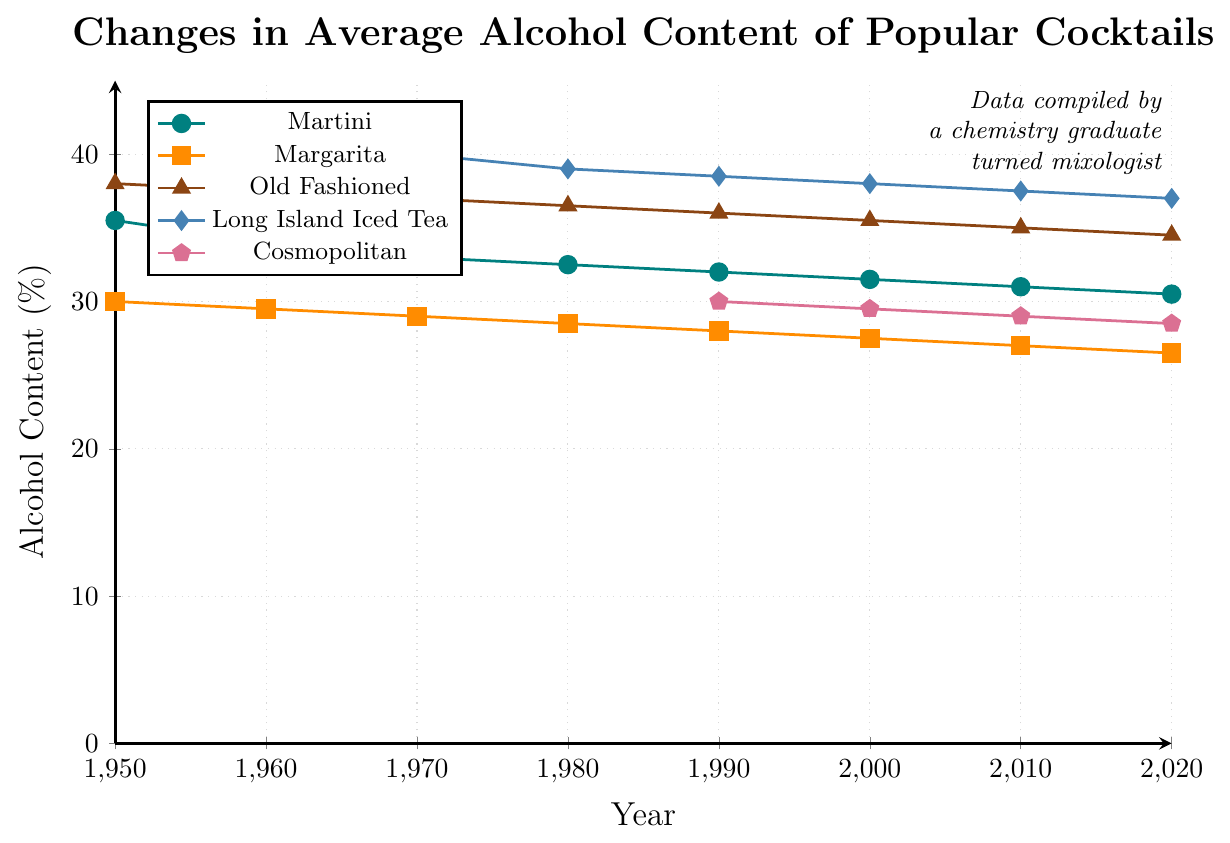Which cocktail had the highest alcohol content in 1950? Find the highest data point in the year 1950; Old Fashioned has 38.0%.
Answer: Old Fashioned How did the alcohol content of the Long Island Iced Tea change from 1970 to 2020? Compare the values for Long Island Iced Tea from 1970 (40.0%) to 2020 (37.0%). The change is a decrease from 40.0% to 37.0%, so 40.0% - 37.0% = 3.0%.
Answer: Decreased by 3.0% Which cocktails were not present before 1970? Observing the data series, Long Island Iced Tea appears from 1970, and Cosmopolitan from 1990.
Answer: Long Island Iced Tea, Cosmopolitan By how much did the alcohol content of a Martini decrease from 1950 to 2020? Observe the values for Martini in 1950 (35.5%) and 2020 (30.5%). Calculate the difference: 35.5% - 30.5% = 5.0%.
Answer: Decreased by 5.0% Which cocktail had the smallest decrease in alcohol content over the shown period? Calculate the decrease for all cocktails: Martini (5.0%), Margarita (3.5%), Old Fashioned (3.5%), Long Island Iced Tea (3.0%), Cosmopolitan (1.5%). Cosmopolitan has the smallest decrease of 1.5%.
Answer: Cosmopolitan What was the average alcohol content of all cocktails in the year 1980? Sum the values for each cocktail in 1980: 32.5 (Martini) + 28.5 (Margarita) + 36.5 (Old Fashioned) + 39.0 (Long Island Iced Tea) = 136.5, then divide by the number of cocktails (4): 136.5 / 4 = 34.125%.
Answer: 34.13% How does the drop in alcohol content of the Martini compare with the Margarita from 1950 to 2020? Martini: 35.5% to 30.5% (drop of 5.0%). Margarita: 30.0% to 26.5% (drop of 3.5%). Martini's drop is 5.0% - 3.5% = 1.5% more than Margarita's.
Answer: Martini dropped 1.5% more What year did Martini reach an alcohol content of 32%? Identify the year when Martini's alcohol content is 32%: it occurred in 1990.
Answer: 1990 What trend do you observe for Old Fashioned from 1950 to 2020? Observe the consistent decrease in values for Old Fashioned from 38.0% (1950) to 34.5% (2020).
Answer: Decreasing trend Which cocktail had the highest average alcohol content over the entire period? Calculate the average for each: Martini (33.125), Margarita (28.25), Old Fashioned (36.5), Long Island Iced Tea (38.25), Cosmopolitan (29.25). Long Island Iced Tea has the highest average at 38.25%.
Answer: Long Island Iced Tea 